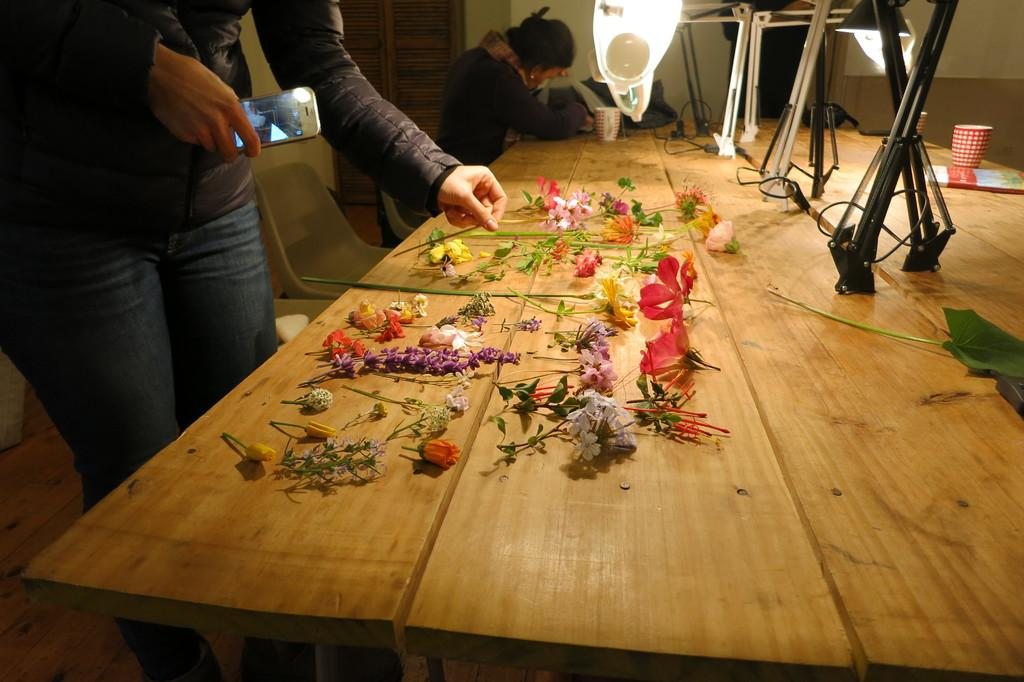What type of decoration is on the table in the image? There are flowers on the table in the image. What else can be seen on the table? There is a cup and a light and stand on the table. Who is present near the table? There are two persons near the table. What type of furniture is near the table? There are chairs near the table. What type of amusement can be seen in the background of the image? There is no amusement or background visible in the image; it only shows a table with objects and people near it. 